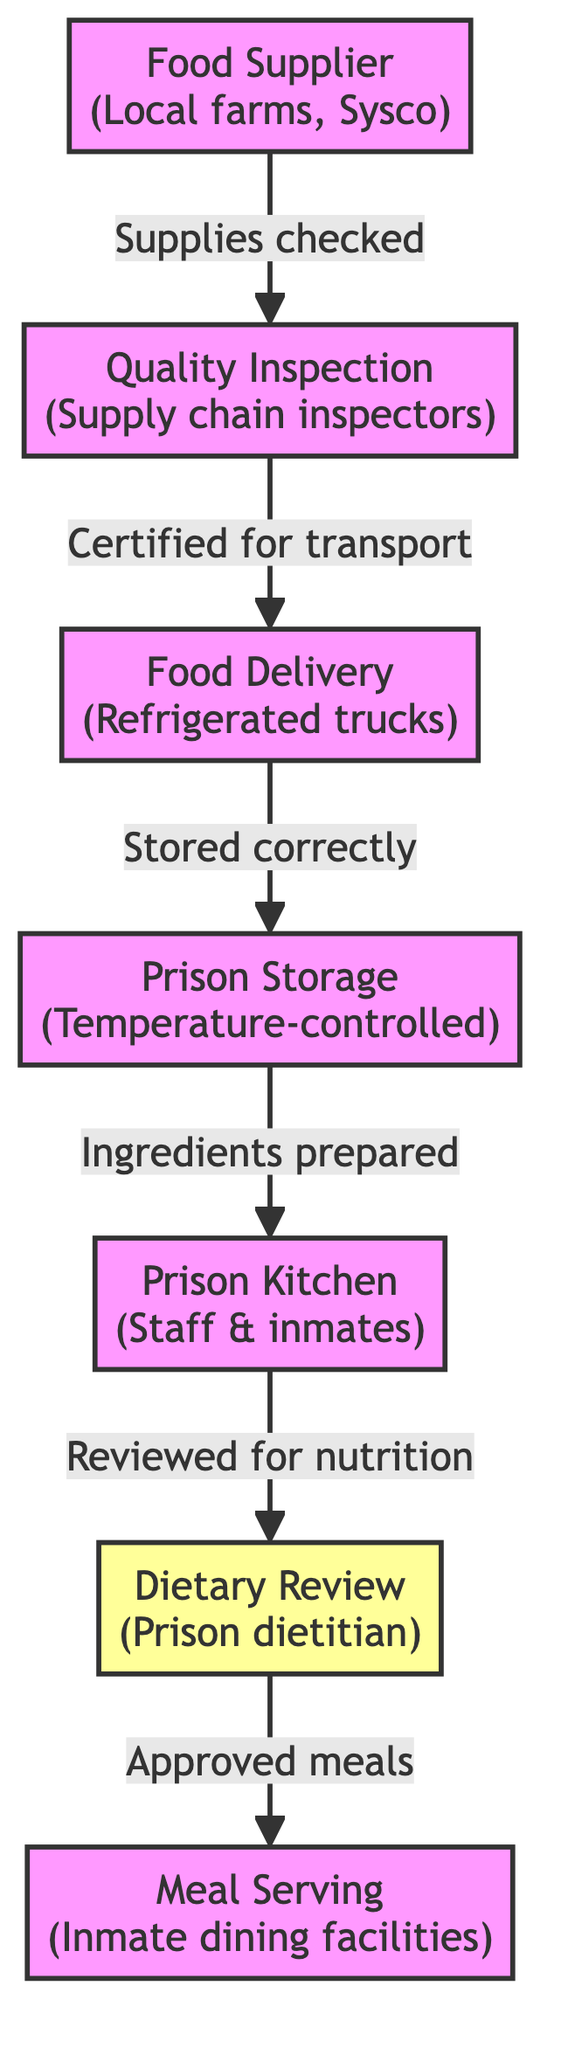What is the first node in the diagram? The first node is the Food Supplier, which indicates the source of food items coming from local farms and Sysco.
Answer: Food Supplier How many nodes are in the flowchart? There are seven nodes in the diagram: Food Supplier, Quality Inspection, Food Delivery, Prison Storage, Prison Kitchen, Dietary Review, and Meal Serving.
Answer: Seven Which node comes after Quality Inspection? The node that comes after Quality Inspection is Food Delivery, which represents the transportation of certified food supplies.
Answer: Food Delivery What is the role of the Dietary Review node? The Dietary Review node indicates that the meals prepared in the kitchen are reviewed for nutritional value by a prison dietitian before being served.
Answer: Approved meals How do food items get from the supplier to the serving stage? Food items move from the Food Supplier to Quality Inspection, then to Food Delivery, followed by Prison Storage, then the Prison Kitchen, further to Dietary Review, and finally to Meal Serving. This shows the complete flow and checks in the food supply chain.
Answer: Through Quality Inspection, Food Delivery, Prison Storage, Prison Kitchen, Dietary Review What is required for the food delivery to happen? The food must be certified for transport during the Quality Inspection. This means it has passed checks to ensure it is safe and fit for consumption before it is delivered.
Answer: Certified for transport Which node includes the involvement of kitchen staff and inmates? The node that includes the involvement of kitchen staff and inmates is the Prison Kitchen, where meals are prepared and managed.
Answer: Prison Kitchen What is the last step before inmates receive their meals? The last step before inmates receive their meals is the Meal Serving, where the approved meals are served in the inmate dining facilities.
Answer: Meal Serving 